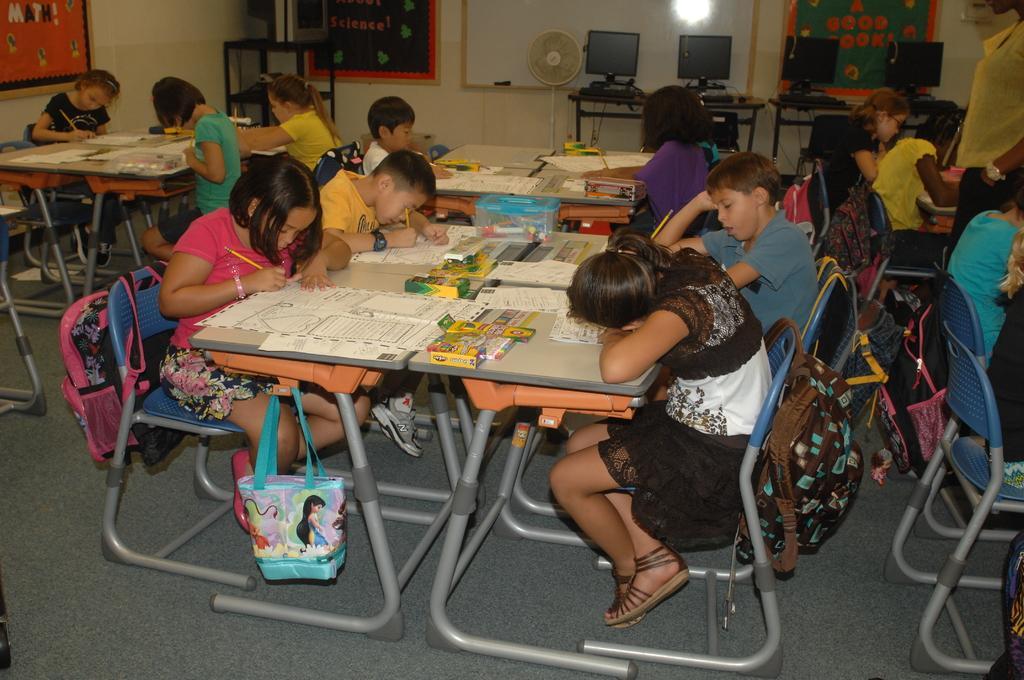How would you summarize this image in a sentence or two? Inside the room there are many kids sitting on the chair. And in front of them there are some tables. On the table there are papers, boxes , pencils. They are drawing something on their paper. Into the right side there are some monitors on the table. And in the middle we can see a table fan. In the left side there is a poster on the wall. There are some school bags. 